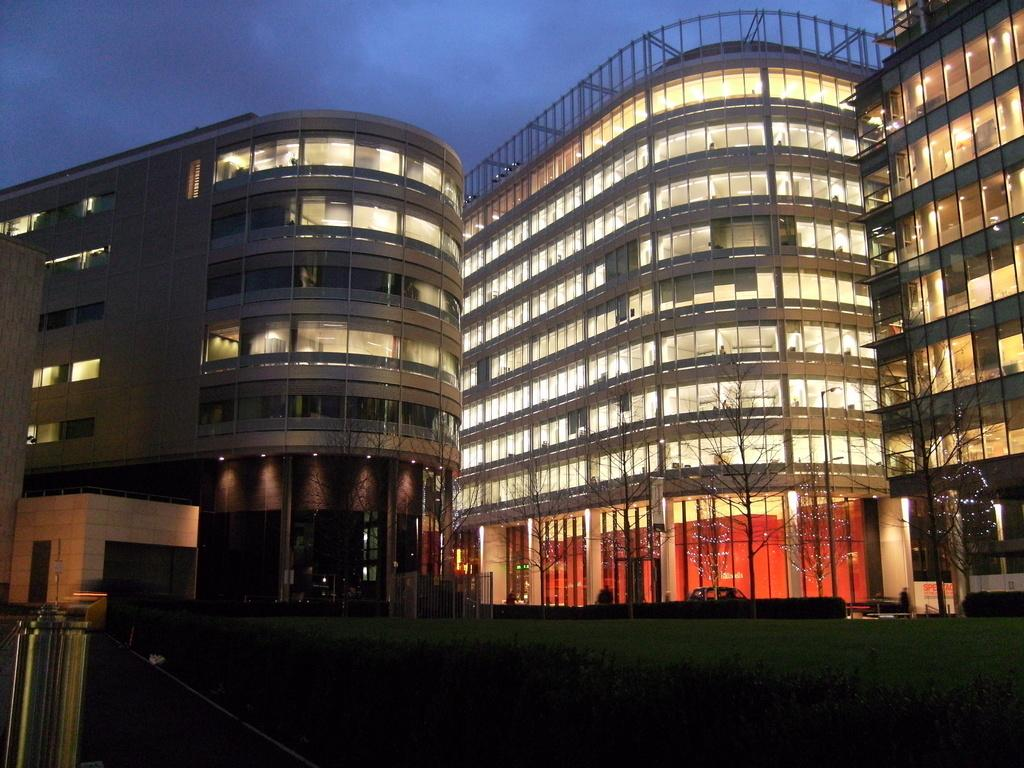What type of vegetation can be seen in the image? There is grass, plants, and trees in the image. What type of structures are present in the image? There are buildings in the image. What type of illumination is visible in the image? There are lights in the image. What can be seen in the background of the image? The sky is visible in the background of the image. What type of button can be seen on the animal in the image? There is no animal or button present in the image. How many members are in the group visible in the image? There is no group of people or animals present in the image. 